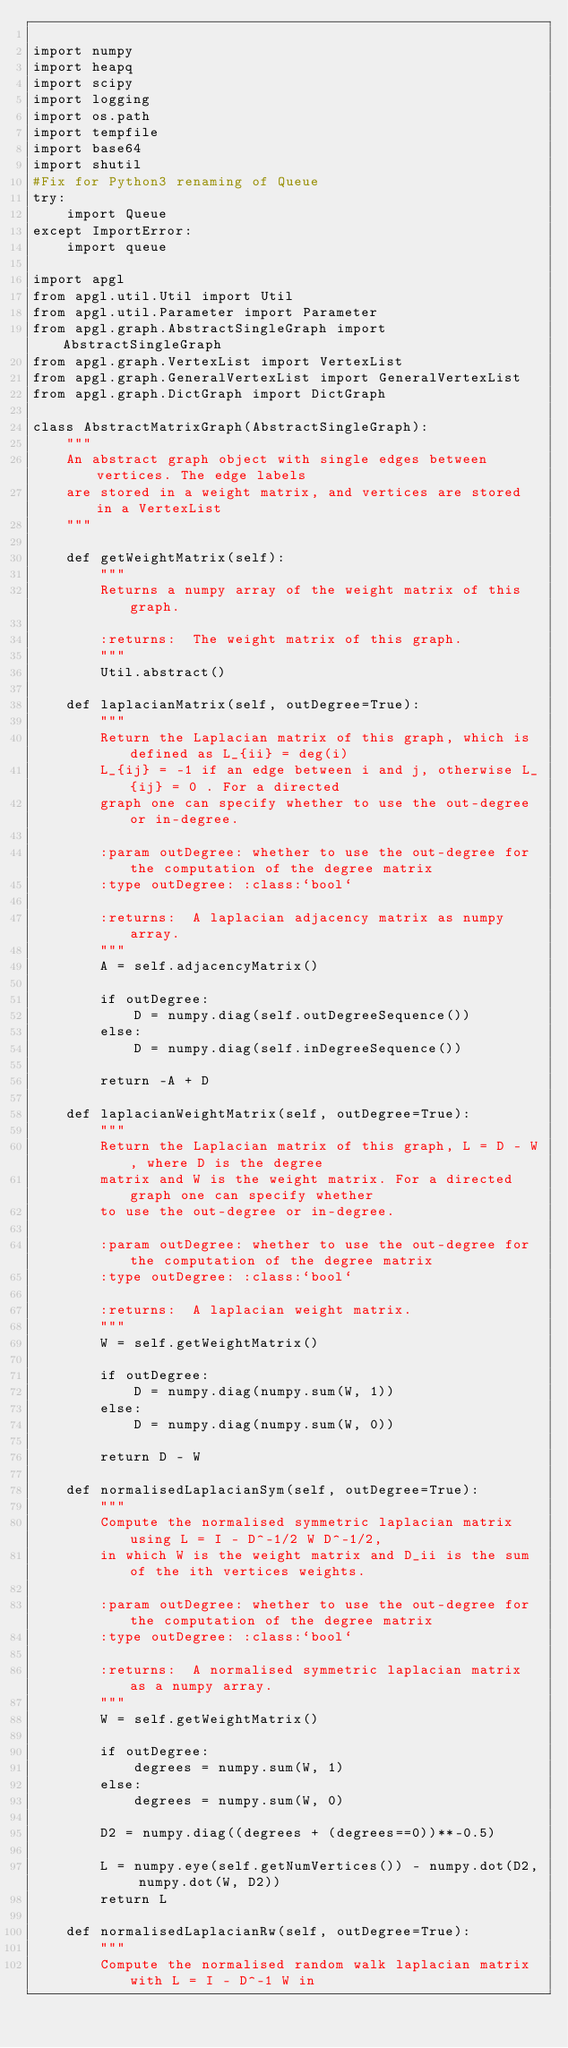Convert code to text. <code><loc_0><loc_0><loc_500><loc_500><_Python_>
import numpy
import heapq
import scipy
import logging
import os.path
import tempfile 
import base64 
import shutil 
#Fix for Python3 renaming of Queue 
try: 
    import Queue 
except ImportError: 
    import queue 

import apgl
from apgl.util.Util import Util
from apgl.util.Parameter import Parameter
from apgl.graph.AbstractSingleGraph import AbstractSingleGraph
from apgl.graph.VertexList import VertexList
from apgl.graph.GeneralVertexList import GeneralVertexList
from apgl.graph.DictGraph import DictGraph

class AbstractMatrixGraph(AbstractSingleGraph):
    """
    An abstract graph object with single edges between vertices. The edge labels
    are stored in a weight matrix, and vertices are stored in a VertexList 
    """

    def getWeightMatrix(self):
        """
        Returns a numpy array of the weight matrix of this graph.

        :returns:  The weight matrix of this graph. 
        """
        Util.abstract()

    def laplacianMatrix(self, outDegree=True):
        """
        Return the Laplacian matrix of this graph, which is defined as L_{ii} = deg(i)
        L_{ij} = -1 if an edge between i and j, otherwise L_{ij} = 0 . For a directed
        graph one can specify whether to use the out-degree or in-degree.

        :param outDegree: whether to use the out-degree for the computation of the degree matrix
        :type outDegree: :class:`bool`

        :returns:  A laplacian adjacency matrix as numpy array.
        """
        A = self.adjacencyMatrix()

        if outDegree:
            D = numpy.diag(self.outDegreeSequence())
        else:
            D = numpy.diag(self.inDegreeSequence())

        return -A + D

    def laplacianWeightMatrix(self, outDegree=True):
        """
        Return the Laplacian matrix of this graph, L = D - W, where D is the degree
        matrix and W is the weight matrix. For a directed graph one can specify whether
        to use the out-degree or in-degree.

        :param outDegree: whether to use the out-degree for the computation of the degree matrix
        :type outDegree: :class:`bool`

        :returns:  A laplacian weight matrix.
        """
        W = self.getWeightMatrix()

        if outDegree:
            D = numpy.diag(numpy.sum(W, 1))
        else:
            D = numpy.diag(numpy.sum(W, 0))

        return D - W

    def normalisedLaplacianSym(self, outDegree=True):
        """
        Compute the normalised symmetric laplacian matrix using L = I - D^-1/2 W D^-1/2,
        in which W is the weight matrix and D_ii is the sum of the ith vertices weights.

        :param outDegree: whether to use the out-degree for the computation of the degree matrix
        :type outDegree: :class:`bool`

        :returns:  A normalised symmetric laplacian matrix as a numpy array.
        """
        W = self.getWeightMatrix()

        if outDegree:
            degrees = numpy.sum(W, 1)
        else:
            degrees = numpy.sum(W, 0)

        D2 = numpy.diag((degrees + (degrees==0))**-0.5)
        
        L = numpy.eye(self.getNumVertices()) - numpy.dot(D2, numpy.dot(W, D2))
        return L

    def normalisedLaplacianRw(self, outDegree=True):
        """
        Compute the normalised random walk laplacian matrix with L = I - D^-1 W in</code> 